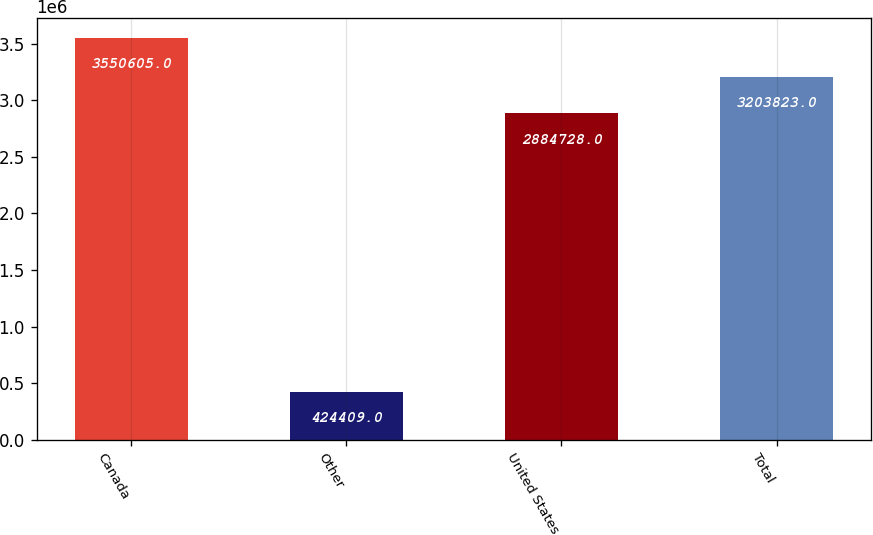<chart> <loc_0><loc_0><loc_500><loc_500><bar_chart><fcel>Canada<fcel>Other<fcel>United States<fcel>Total<nl><fcel>3.5506e+06<fcel>424409<fcel>2.88473e+06<fcel>3.20382e+06<nl></chart> 